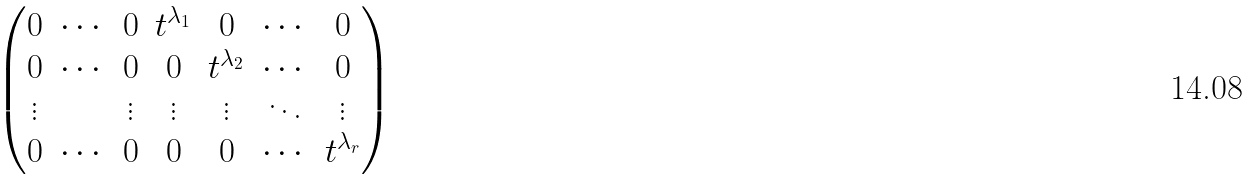Convert formula to latex. <formula><loc_0><loc_0><loc_500><loc_500>\begin{pmatrix} 0 & \cdots & 0 & t ^ { \lambda _ { 1 } } & 0 & \cdots & 0 \\ 0 & \cdots & 0 & 0 & t ^ { \lambda _ { 2 } } & \cdots & 0 \\ \vdots & & \vdots & \vdots & \vdots & \ddots & \vdots \\ 0 & \cdots & 0 & 0 & 0 & \cdots & t ^ { \lambda _ { r } } \end{pmatrix}</formula> 